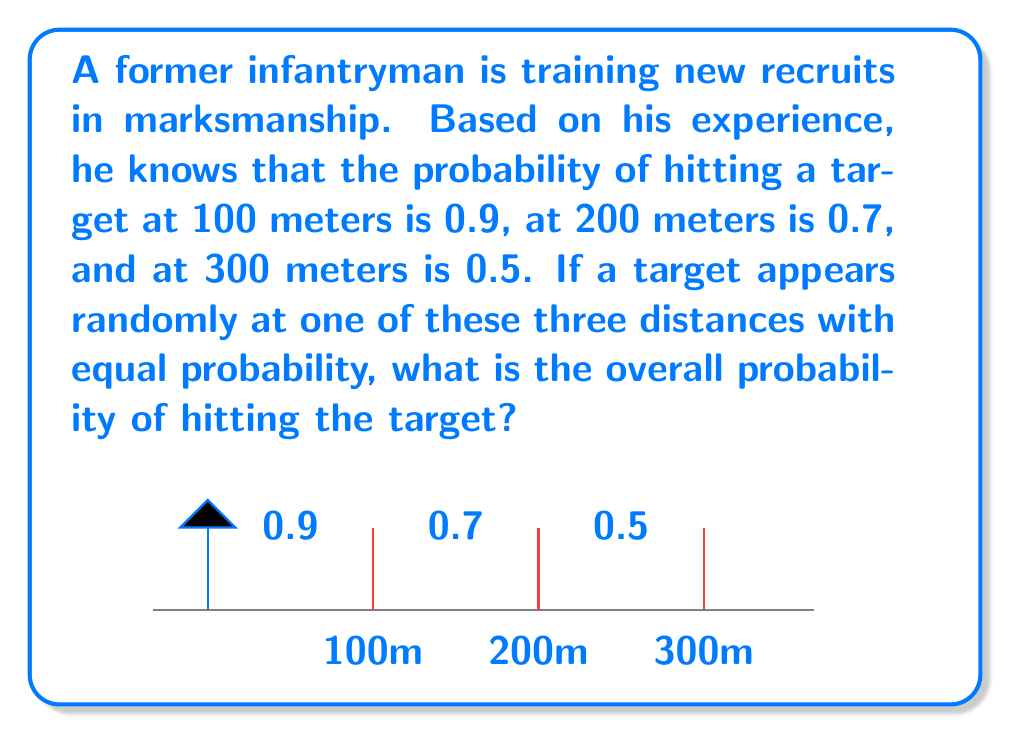Solve this math problem. Let's approach this step-by-step:

1) First, we need to understand what the question is asking. We're looking for the overall probability of hitting the target, given that it can appear at any of the three distances with equal probability.

2) We're given the following probabilities:
   - P(hit | 100m) = 0.9
   - P(hit | 200m) = 0.7
   - P(hit | 300m) = 0.5

3) The probability of the target appearing at each distance is equal, so:
   P(100m) = P(200m) = P(300m) = $\frac{1}{3}$

4) We can use the law of total probability to solve this problem. The formula is:

   $$P(\text{hit}) = P(\text{hit}|100\text{m}) \cdot P(100\text{m}) + P(\text{hit}|200\text{m}) \cdot P(200\text{m}) + P(\text{hit}|300\text{m}) \cdot P(300\text{m})$$

5) Now, let's substitute the values:

   $$P(\text{hit}) = 0.9 \cdot \frac{1}{3} + 0.7 \cdot \frac{1}{3} + 0.5 \cdot \frac{1}{3}$$

6) Simplify:

   $$P(\text{hit}) = \frac{0.9 + 0.7 + 0.5}{3} = \frac{2.1}{3} = 0.7$$

Therefore, the overall probability of hitting the target is 0.7 or 70%.
Answer: 0.7 